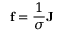<formula> <loc_0><loc_0><loc_500><loc_500>f = { \frac { 1 } { \sigma } } J</formula> 